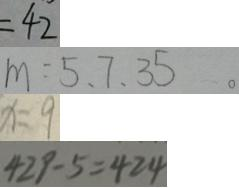<formula> <loc_0><loc_0><loc_500><loc_500>= 4 2 
 m = 5 、 7 、 3 5 。 
 x = 9 
 4 2 9 - 5 = 4 2 4</formula> 